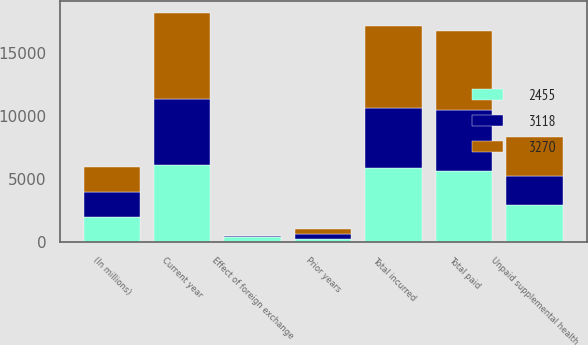Convert chart. <chart><loc_0><loc_0><loc_500><loc_500><stacked_bar_chart><ecel><fcel>(In millions)<fcel>Unpaid supplemental health<fcel>Current year<fcel>Prior years<fcel>Total incurred<fcel>Total paid<fcel>Effect of foreign exchange<nl><fcel>3270<fcel>2009<fcel>3105<fcel>6864<fcel>398<fcel>6466<fcel>6301<fcel>19<nl><fcel>2455<fcel>2008<fcel>2959<fcel>6127<fcel>253<fcel>5874<fcel>5653<fcel>406<nl><fcel>3118<fcel>2007<fcel>2332<fcel>5225<fcel>401<fcel>4824<fcel>4857<fcel>72<nl></chart> 